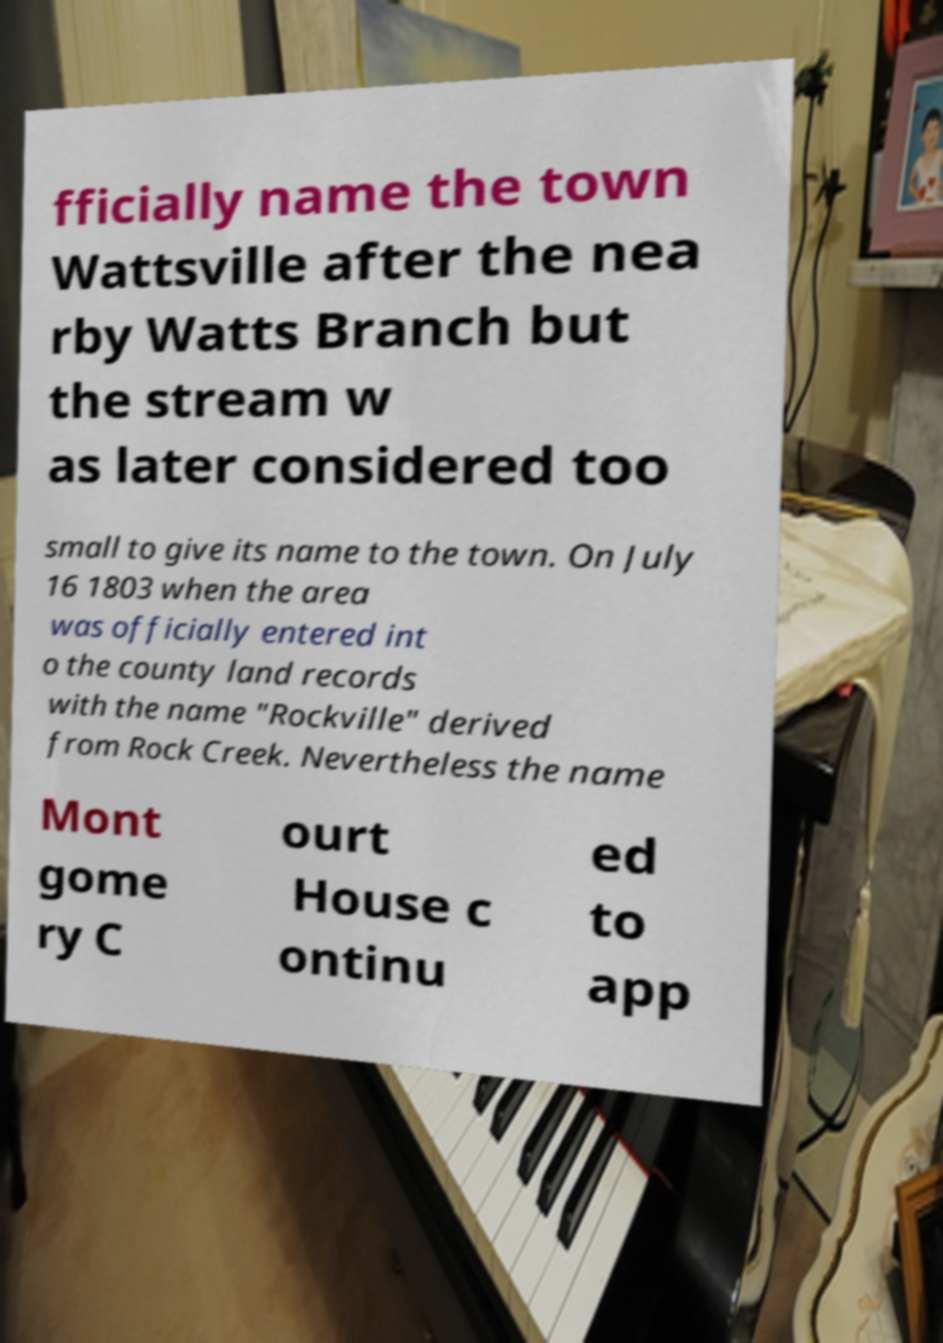There's text embedded in this image that I need extracted. Can you transcribe it verbatim? fficially name the town Wattsville after the nea rby Watts Branch but the stream w as later considered too small to give its name to the town. On July 16 1803 when the area was officially entered int o the county land records with the name "Rockville" derived from Rock Creek. Nevertheless the name Mont gome ry C ourt House c ontinu ed to app 